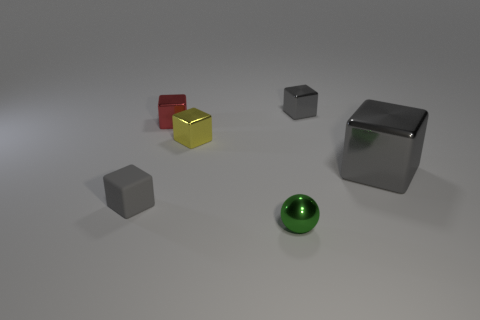Subtract all purple cylinders. How many gray cubes are left? 3 Subtract all large gray shiny cubes. How many cubes are left? 4 Subtract all yellow cubes. How many cubes are left? 4 Subtract all blue cubes. Subtract all cyan spheres. How many cubes are left? 5 Add 2 big metallic cubes. How many objects exist? 8 Subtract all blocks. How many objects are left? 1 Subtract all yellow metallic things. Subtract all metal balls. How many objects are left? 4 Add 3 small rubber cubes. How many small rubber cubes are left? 4 Add 2 big blue cylinders. How many big blue cylinders exist? 2 Subtract 0 purple balls. How many objects are left? 6 